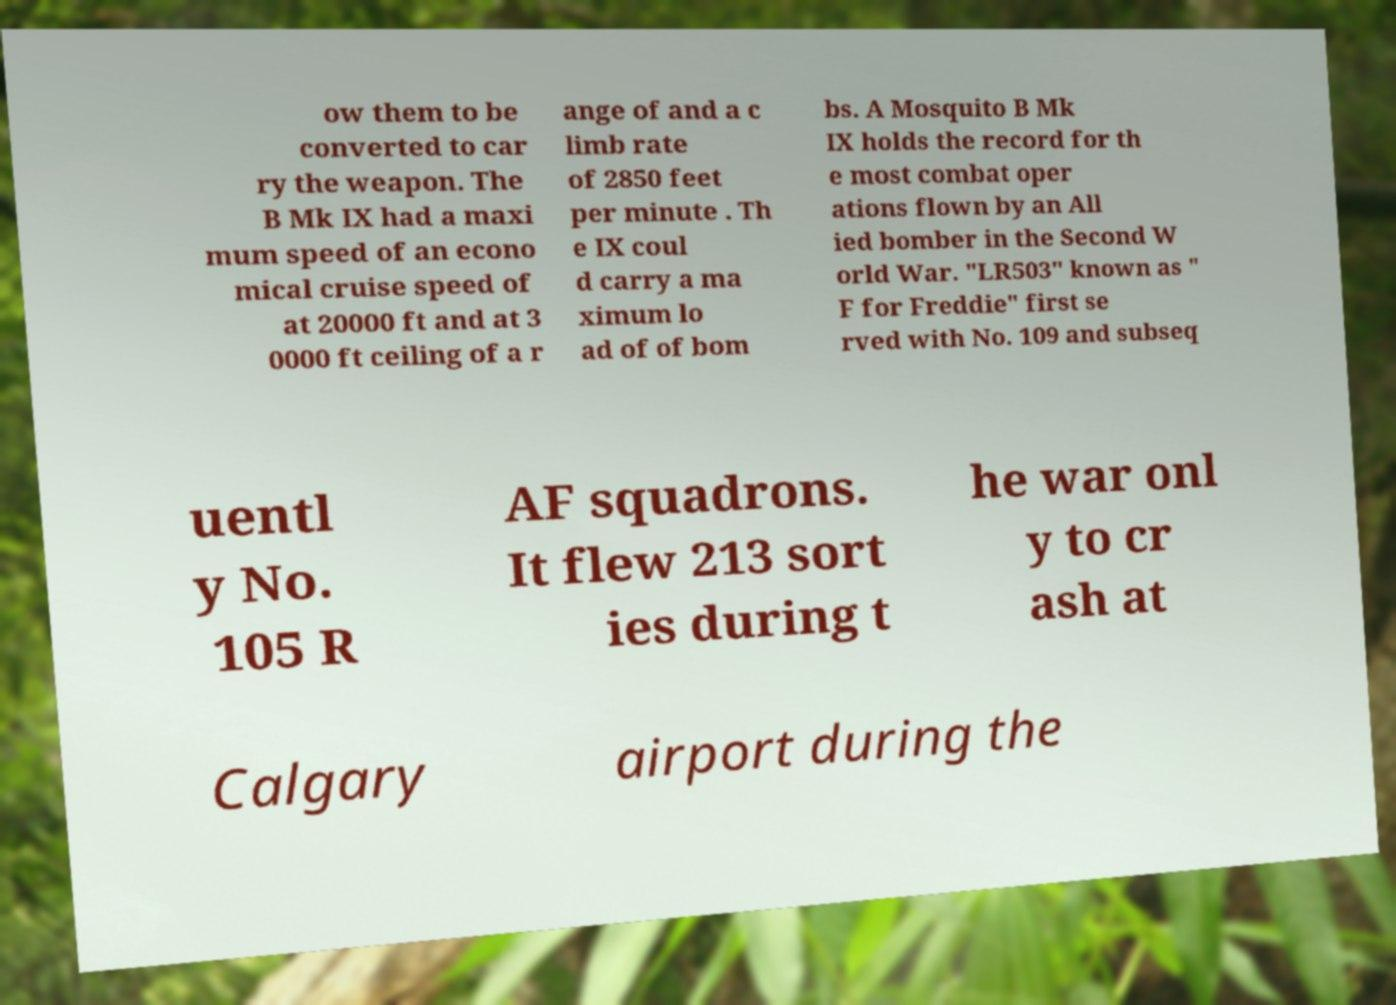Could you assist in decoding the text presented in this image and type it out clearly? ow them to be converted to car ry the weapon. The B Mk IX had a maxi mum speed of an econo mical cruise speed of at 20000 ft and at 3 0000 ft ceiling of a r ange of and a c limb rate of 2850 feet per minute . Th e IX coul d carry a ma ximum lo ad of of bom bs. A Mosquito B Mk IX holds the record for th e most combat oper ations flown by an All ied bomber in the Second W orld War. "LR503" known as " F for Freddie" first se rved with No. 109 and subseq uentl y No. 105 R AF squadrons. It flew 213 sort ies during t he war onl y to cr ash at Calgary airport during the 